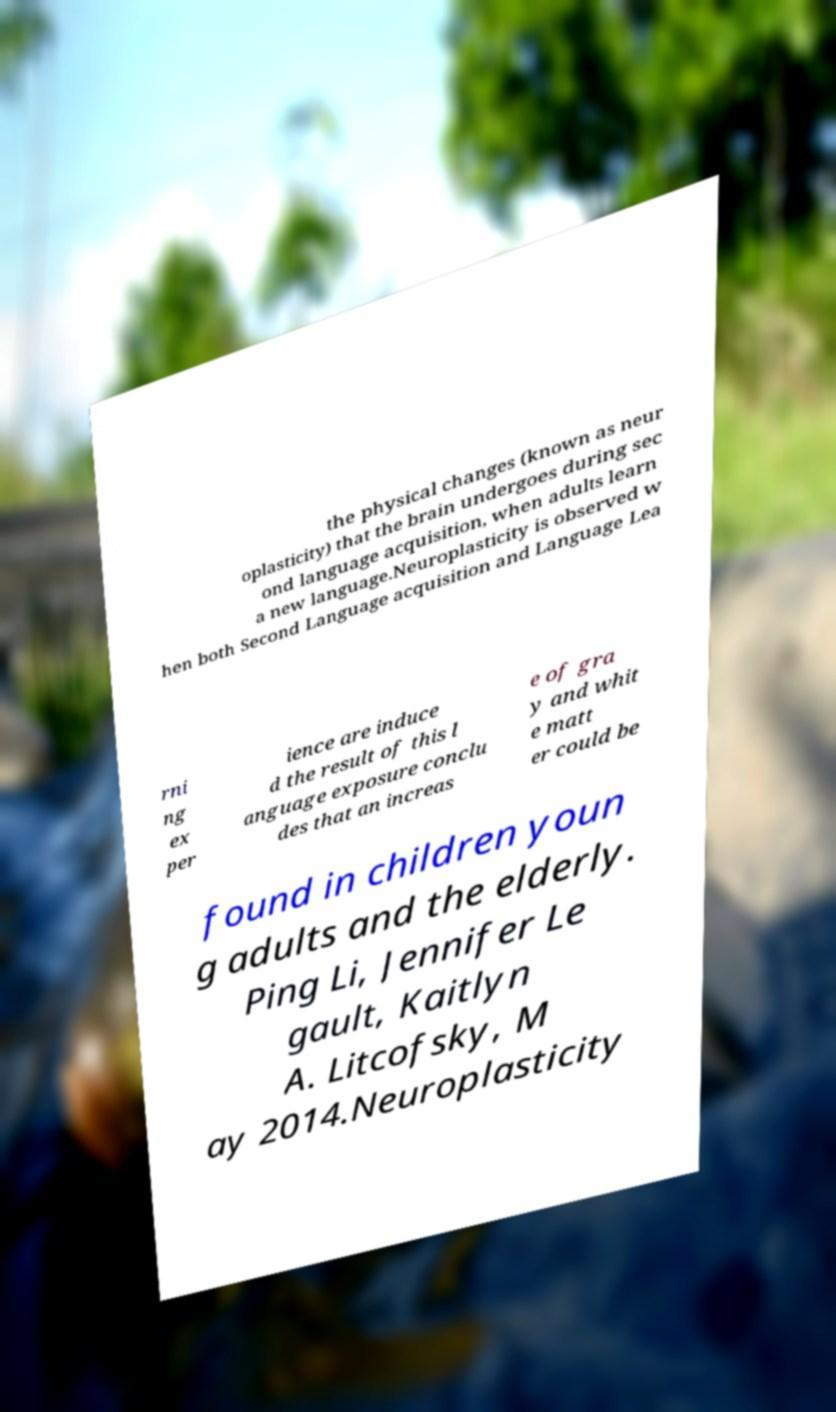Please read and relay the text visible in this image. What does it say? the physical changes (known as neur oplasticity) that the brain undergoes during sec ond language acquisition, when adults learn a new language.Neuroplasticity is observed w hen both Second Language acquisition and Language Lea rni ng ex per ience are induce d the result of this l anguage exposure conclu des that an increas e of gra y and whit e matt er could be found in children youn g adults and the elderly. Ping Li, Jennifer Le gault, Kaitlyn A. Litcofsky, M ay 2014.Neuroplasticity 